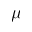<formula> <loc_0><loc_0><loc_500><loc_500>\mu</formula> 